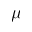<formula> <loc_0><loc_0><loc_500><loc_500>\mu</formula> 